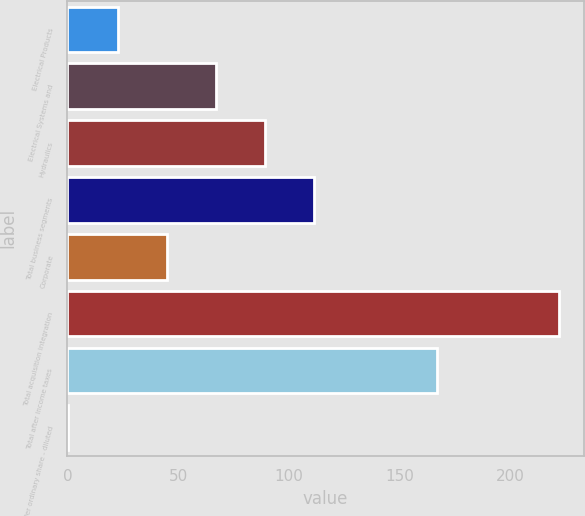Convert chart to OTSL. <chart><loc_0><loc_0><loc_500><loc_500><bar_chart><fcel>Electrical Products<fcel>Electrical Systems and<fcel>Hydraulics<fcel>Total business segments<fcel>Corporate<fcel>Total acquisition integration<fcel>Total after income taxes<fcel>Per ordinary share - diluted<nl><fcel>22.63<fcel>66.93<fcel>89.08<fcel>111.23<fcel>44.78<fcel>222<fcel>167<fcel>0.48<nl></chart> 